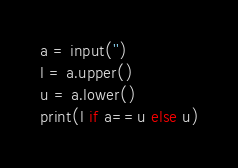Convert code to text. <code><loc_0><loc_0><loc_500><loc_500><_Python_>a = input('')
l = a.upper()
u = a.lower()
print(l if a==u else u)</code> 